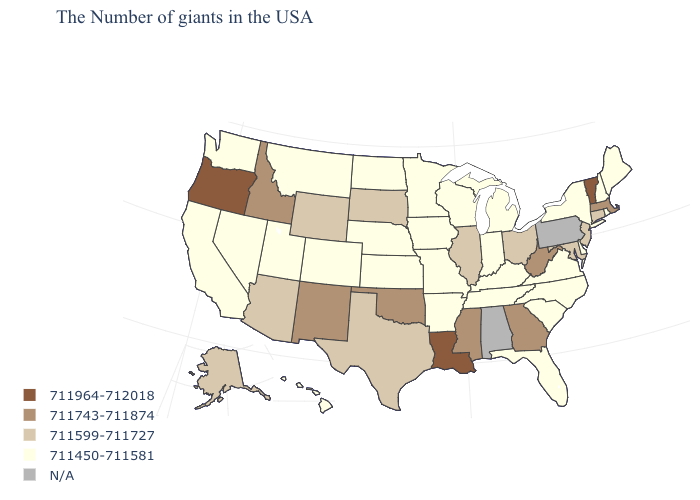What is the highest value in the USA?
Write a very short answer. 711964-712018. What is the value of Texas?
Short answer required. 711599-711727. Which states have the lowest value in the South?
Write a very short answer. Delaware, Virginia, North Carolina, South Carolina, Florida, Kentucky, Tennessee, Arkansas. What is the value of Maine?
Be succinct. 711450-711581. How many symbols are there in the legend?
Short answer required. 5. Name the states that have a value in the range 711599-711727?
Be succinct. Connecticut, New Jersey, Maryland, Ohio, Illinois, Texas, South Dakota, Wyoming, Arizona, Alaska. Name the states that have a value in the range 711450-711581?
Concise answer only. Maine, Rhode Island, New Hampshire, New York, Delaware, Virginia, North Carolina, South Carolina, Florida, Michigan, Kentucky, Indiana, Tennessee, Wisconsin, Missouri, Arkansas, Minnesota, Iowa, Kansas, Nebraska, North Dakota, Colorado, Utah, Montana, Nevada, California, Washington, Hawaii. Which states have the lowest value in the USA?
Keep it brief. Maine, Rhode Island, New Hampshire, New York, Delaware, Virginia, North Carolina, South Carolina, Florida, Michigan, Kentucky, Indiana, Tennessee, Wisconsin, Missouri, Arkansas, Minnesota, Iowa, Kansas, Nebraska, North Dakota, Colorado, Utah, Montana, Nevada, California, Washington, Hawaii. Name the states that have a value in the range 711743-711874?
Concise answer only. Massachusetts, West Virginia, Georgia, Mississippi, Oklahoma, New Mexico, Idaho. Name the states that have a value in the range 711599-711727?
Concise answer only. Connecticut, New Jersey, Maryland, Ohio, Illinois, Texas, South Dakota, Wyoming, Arizona, Alaska. What is the value of Louisiana?
Keep it brief. 711964-712018. Does Iowa have the lowest value in the MidWest?
Be succinct. Yes. Which states hav the highest value in the Northeast?
Answer briefly. Vermont. 